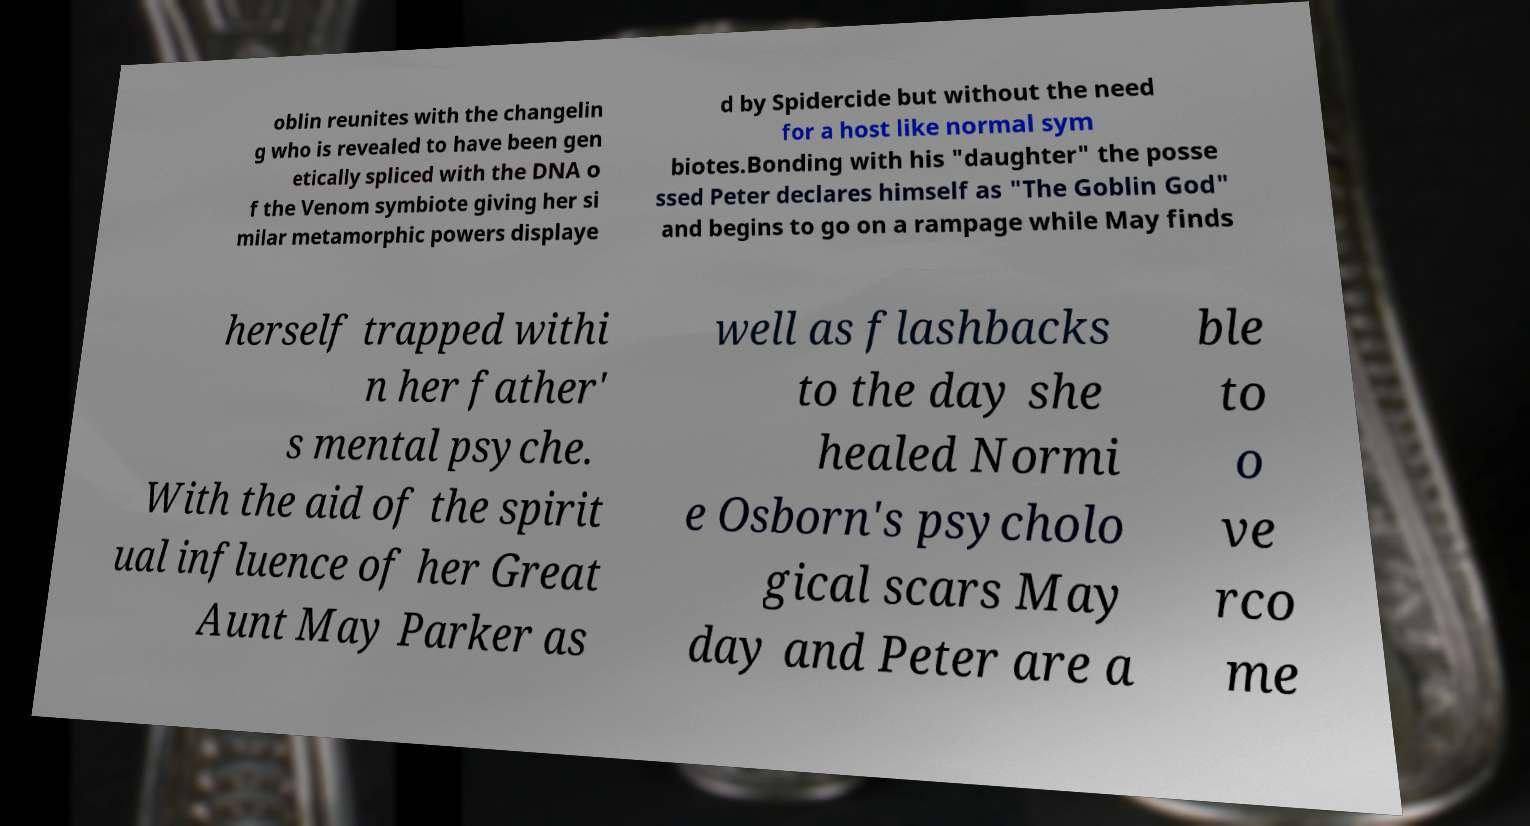Please identify and transcribe the text found in this image. oblin reunites with the changelin g who is revealed to have been gen etically spliced with the DNA o f the Venom symbiote giving her si milar metamorphic powers displaye d by Spidercide but without the need for a host like normal sym biotes.Bonding with his "daughter" the posse ssed Peter declares himself as "The Goblin God" and begins to go on a rampage while May finds herself trapped withi n her father' s mental psyche. With the aid of the spirit ual influence of her Great Aunt May Parker as well as flashbacks to the day she healed Normi e Osborn's psycholo gical scars May day and Peter are a ble to o ve rco me 